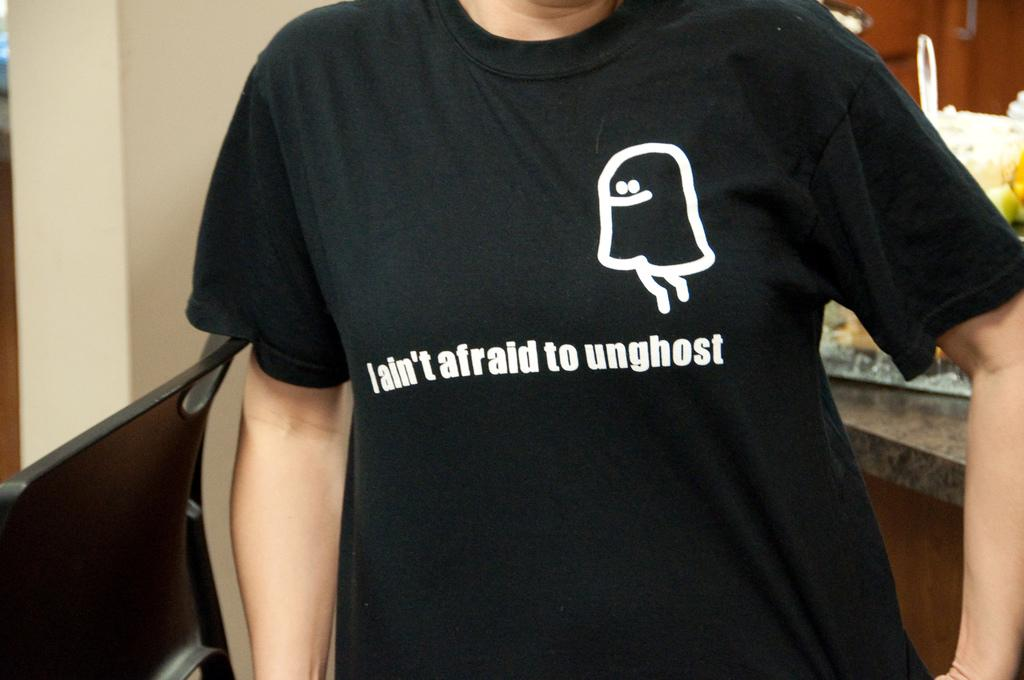Who or what is present in the image? There is a person in the image. What is located beside the person? There is a chair beside the person. What can be seen in the background of the image? There is a wall in the image. What is on a raised surface in the image? There is a platform with some objects in the image. What is used for reflection in the image? There is a mirror in the image. What type of thunder can be heard in the image? There is no thunder present in the image, as it is a still image and not an audio recording. 